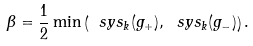<formula> <loc_0><loc_0><loc_500><loc_500>\beta = \frac { 1 } { 2 } \min \left ( \ s y s _ { k } ( g _ { + } ) , \ s y s _ { k } ( g _ { - } ) \right ) .</formula> 